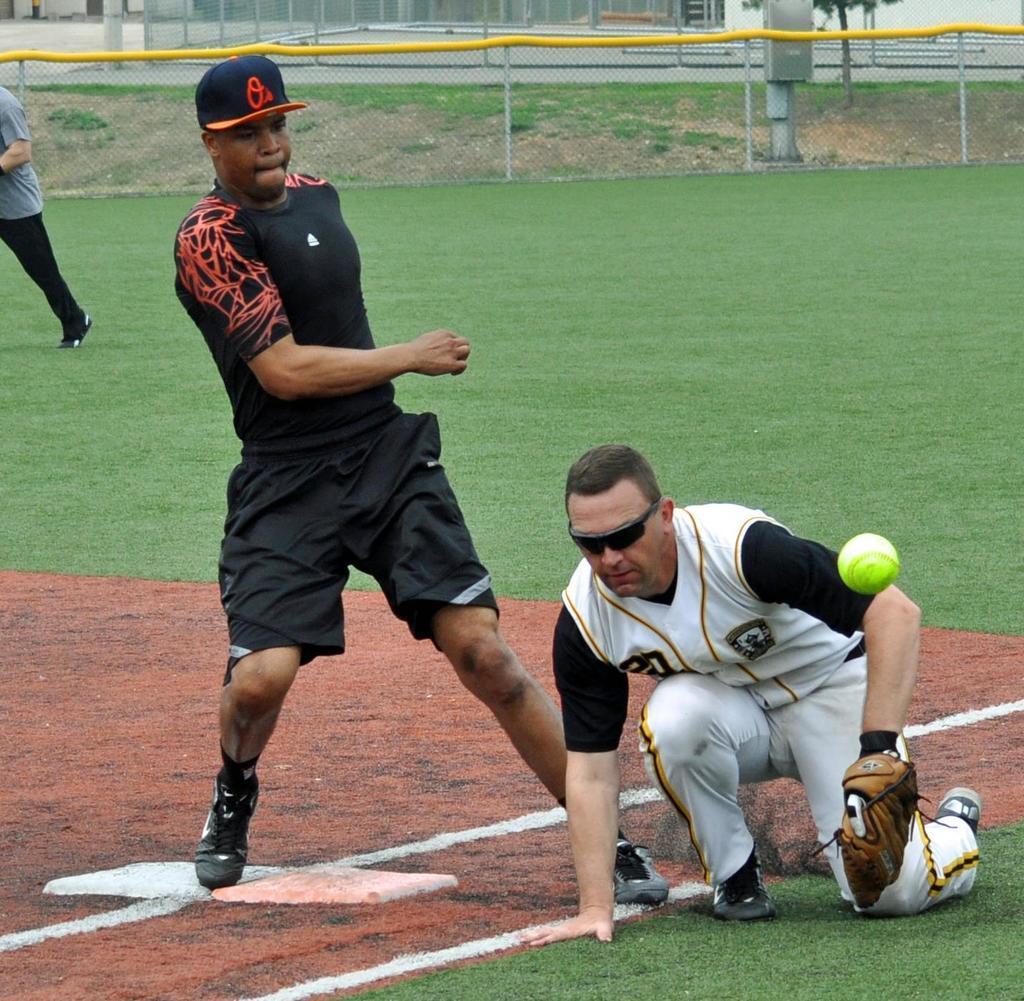Could you give a brief overview of what you see in this image? In the picture I can see few people are playing on the grass and we can see the ball, around there is a fence. 